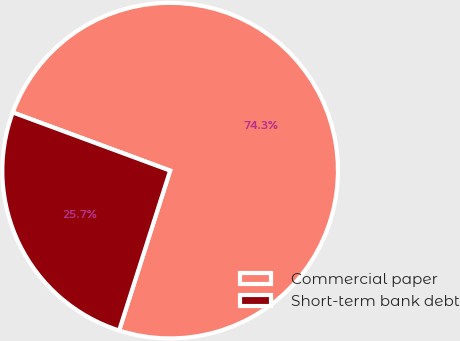Convert chart to OTSL. <chart><loc_0><loc_0><loc_500><loc_500><pie_chart><fcel>Commercial paper<fcel>Short-term bank debt<nl><fcel>74.28%<fcel>25.72%<nl></chart> 